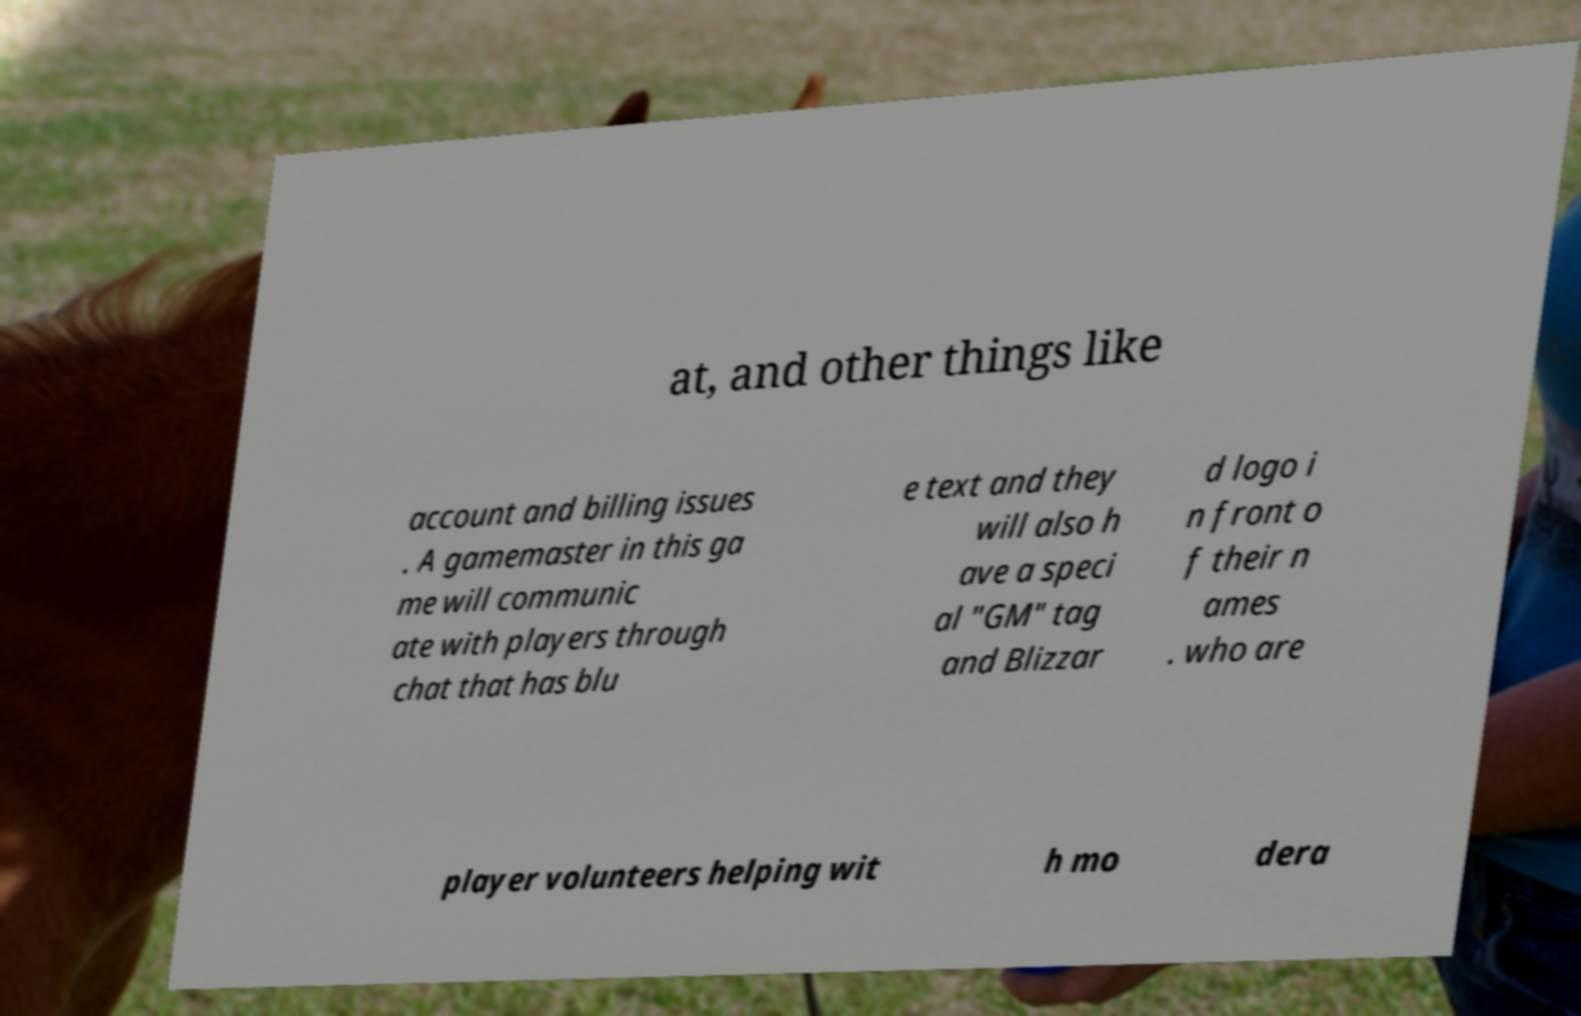Could you assist in decoding the text presented in this image and type it out clearly? at, and other things like account and billing issues . A gamemaster in this ga me will communic ate with players through chat that has blu e text and they will also h ave a speci al "GM" tag and Blizzar d logo i n front o f their n ames . who are player volunteers helping wit h mo dera 